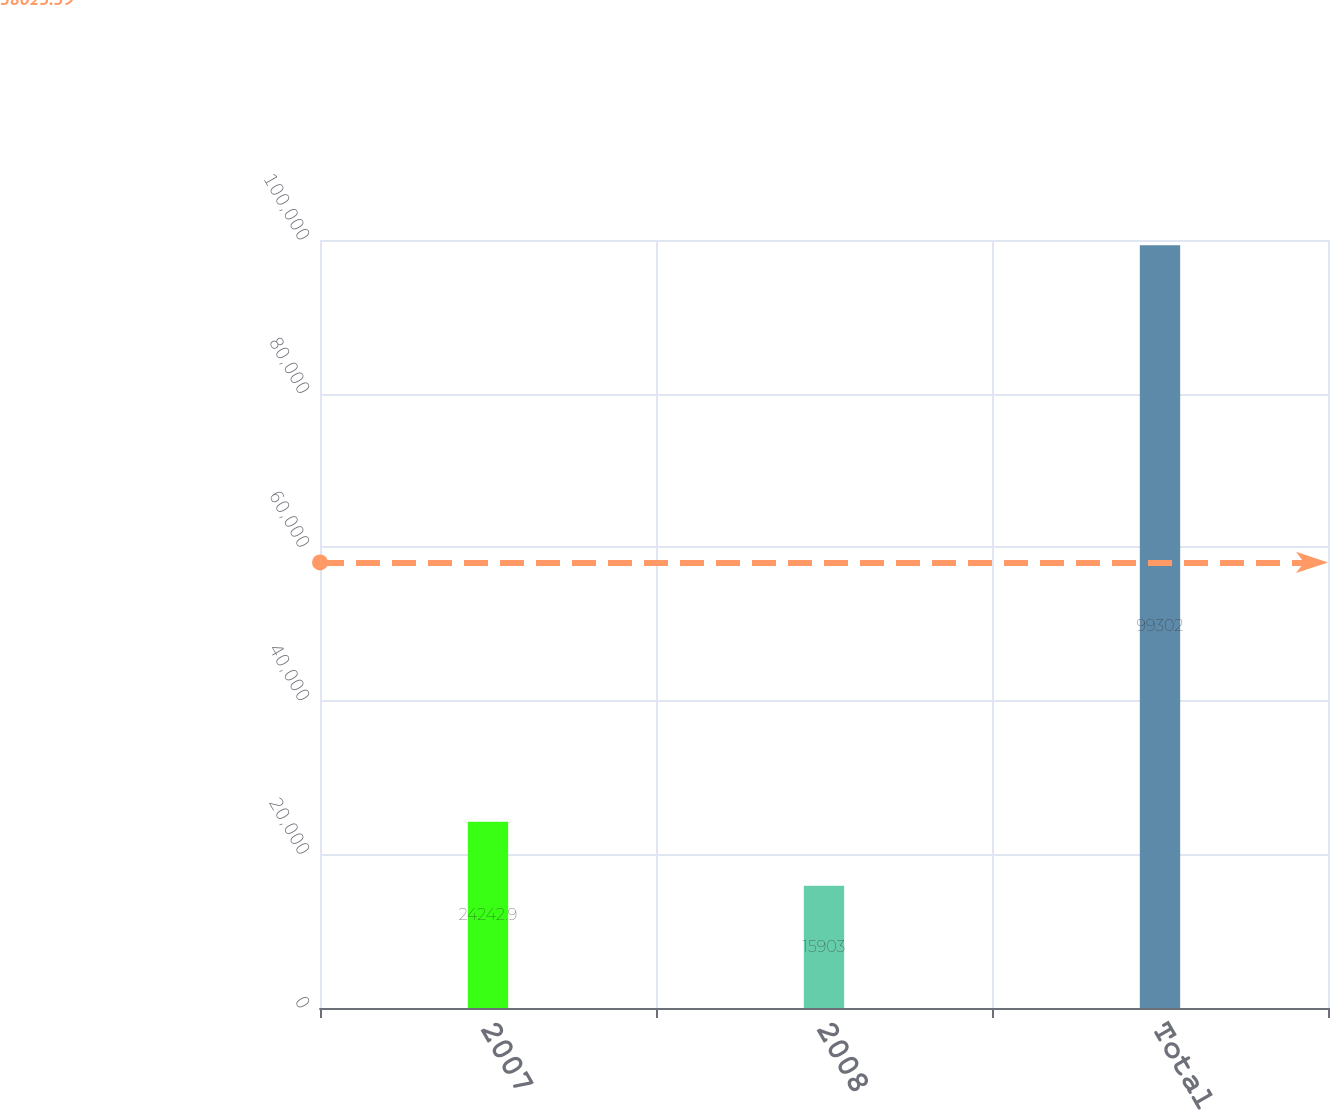Convert chart. <chart><loc_0><loc_0><loc_500><loc_500><bar_chart><fcel>2007<fcel>2008<fcel>Total<nl><fcel>24242.9<fcel>15903<fcel>99302<nl></chart> 